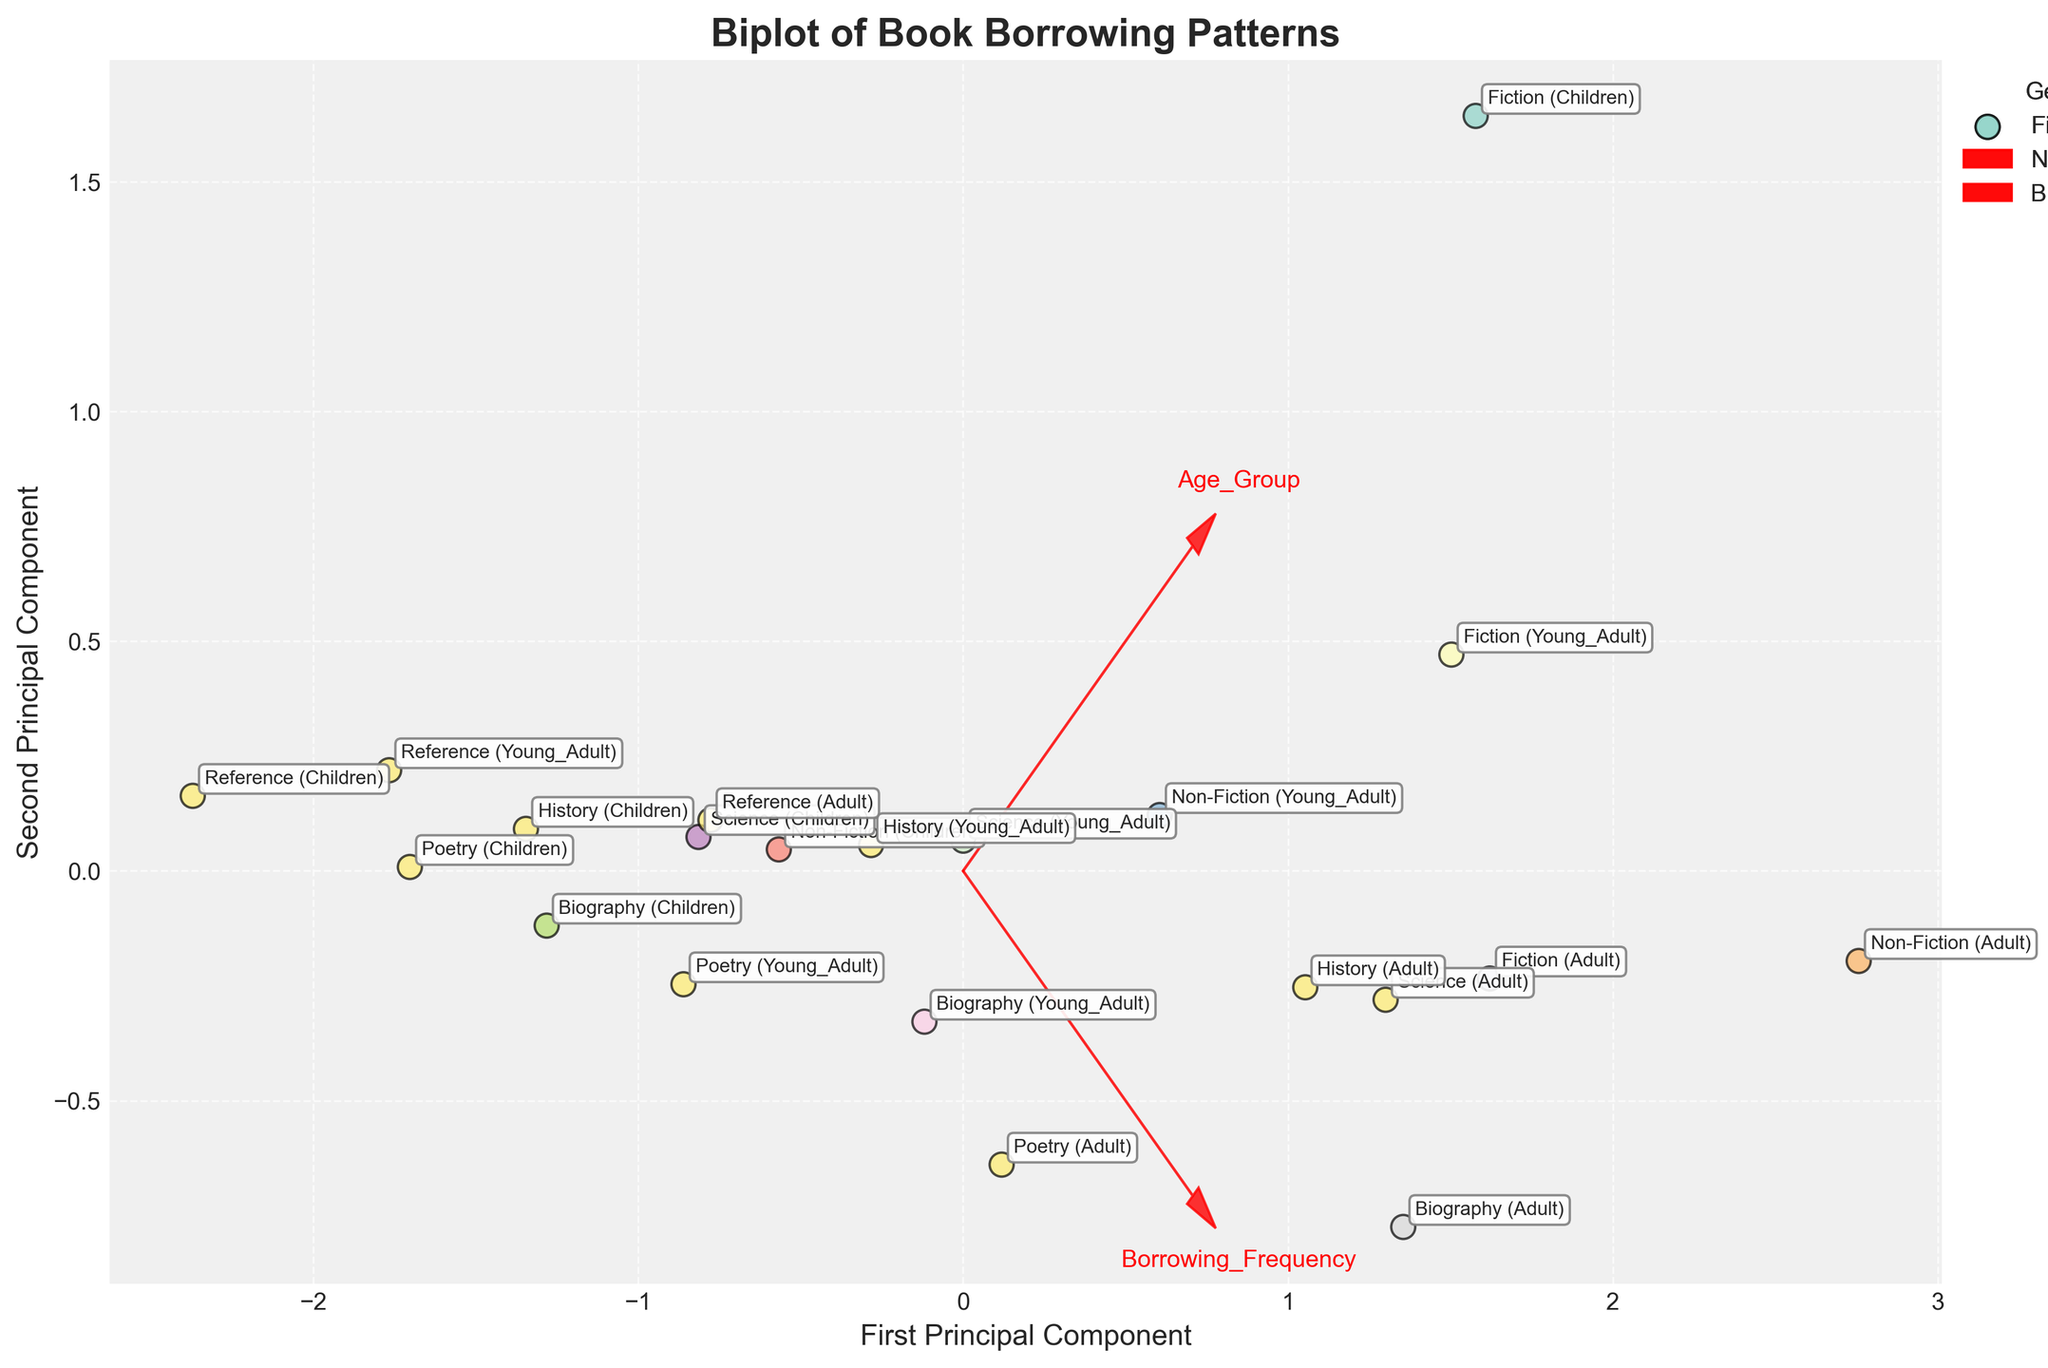What is the title of the figure? The title of the figure is usually found at the top center in a larger font size, which in this case is "Biplot of Book Borrowing Patterns".
Answer: Biplot of Book Borrowing Patterns What are the labels of the axes in the figure? The x-axis and y-axis labels can be identified by the text appearing along the respective axes, which here are "First Principal Component" and "Second Principal Component".
Answer: First Principal Component; Second Principal Component Which genre has the highest borrowing frequency for children? Each data point is labeled with genre and age group. By observing the points, "Fiction (Children)" is positioned furthest in the direction of high Borrowing Frequency.
Answer: Fiction Which age group shows the highest average loan duration for Non-Fiction books? Locate the points labeled "Non-Fiction" and observe their positions in relation to "Average Loan Duration". "Non-Fiction (Adult)" is positioned furthest in this direction.
Answer: Adult Compare the borrowing frequency between Fiction for Young Adult and Adult. Which age group borrows more frequently? Find the points labeled "Fiction (Young Adult)" and "Fiction (Adult)" and compare their positions along the Borrowing Frequency direction. "Fiction (Young Adult)" is positioned furthest along the Borrowing Frequency component.
Answer: Young Adult What can you infer about the average loan duration for Reference books versus Poetry books for Adults? Compare the points labeled "Reference (Adult)" and "Poetry (Adult)" along the Average Loan Duration direction. "Poetry (Adult)" is positioned further along this direction.
Answer: Poetry has a higher average loan duration Which genre and age group combination show the shortest average loan duration? Look for the lowest point along the Average Loan Duration direction. "Reference (Children)" is positioned closest to this direction's origin.
Answer: Reference (Children) Does the borrowing frequency for Science books vary more for children or young adults? Compare the spread of points "Science (Children)" and "Science (Young Adult)" along the Borrowing Frequency direction. The relative position and distance indicate the variance.
Answer: Young Adults have more variation Identify the point associated with the highest average loan duration in the figure. Locate the point furthest along the component representing "Average Loan Duration". The label is "Non-Fiction (Adult)".
Answer: Non-Fiction (Adult) Is there a noticeable trend between Borrowing Frequency and Average Loan Duration for any specific genre? Observe the direction of the arrows and clustering of labels for each genre. For example, Fiction shows a higher borrowing frequency with relatively shorter loan durations, while Non-Fiction shows the opposite trend.
Answer: Fiction: high frequency, short duration; Non-Fiction: moderate frequency, long duration 